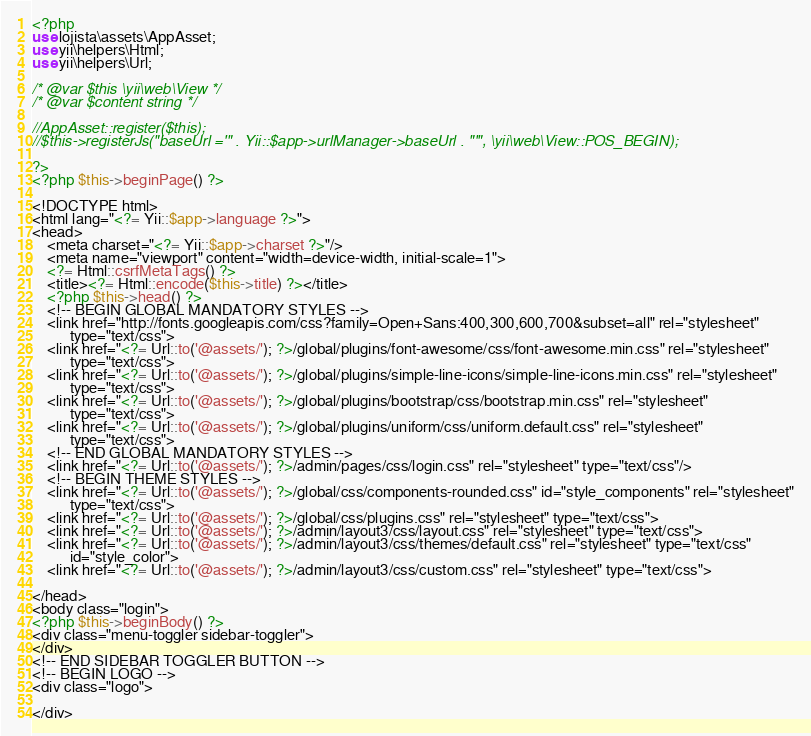<code> <loc_0><loc_0><loc_500><loc_500><_PHP_><?php
use lojista\assets\AppAsset;
use yii\helpers\Html;
use yii\helpers\Url;

/* @var $this \yii\web\View */
/* @var $content string */

//AppAsset::register($this);
//$this->registerJs("baseUrl ='" . Yii::$app->urlManager->baseUrl . "'", \yii\web\View::POS_BEGIN);

?>
<?php $this->beginPage() ?>

<!DOCTYPE html>
<html lang="<?= Yii::$app->language ?>">
<head>
    <meta charset="<?= Yii::$app->charset ?>"/>
    <meta name="viewport" content="width=device-width, initial-scale=1">
    <?= Html::csrfMetaTags() ?>
    <title><?= Html::encode($this->title) ?></title>
    <?php $this->head() ?>
    <!-- BEGIN GLOBAL MANDATORY STYLES -->
    <link href="http://fonts.googleapis.com/css?family=Open+Sans:400,300,600,700&subset=all" rel="stylesheet"
          type="text/css">
    <link href="<?= Url::to('@assets/'); ?>/global/plugins/font-awesome/css/font-awesome.min.css" rel="stylesheet"
          type="text/css">
    <link href="<?= Url::to('@assets/'); ?>/global/plugins/simple-line-icons/simple-line-icons.min.css" rel="stylesheet"
          type="text/css">
    <link href="<?= Url::to('@assets/'); ?>/global/plugins/bootstrap/css/bootstrap.min.css" rel="stylesheet"
          type="text/css">
    <link href="<?= Url::to('@assets/'); ?>/global/plugins/uniform/css/uniform.default.css" rel="stylesheet"
          type="text/css">
    <!-- END GLOBAL MANDATORY STYLES -->
    <link href="<?= Url::to('@assets/'); ?>/admin/pages/css/login.css" rel="stylesheet" type="text/css"/>
    <!-- BEGIN THEME STYLES -->
    <link href="<?= Url::to('@assets/'); ?>/global/css/components-rounded.css" id="style_components" rel="stylesheet"
          type="text/css">
    <link href="<?= Url::to('@assets/'); ?>/global/css/plugins.css" rel="stylesheet" type="text/css">
    <link href="<?= Url::to('@assets/'); ?>/admin/layout3/css/layout.css" rel="stylesheet" type="text/css">
    <link href="<?= Url::to('@assets/'); ?>/admin/layout3/css/themes/default.css" rel="stylesheet" type="text/css"
          id="style_color">
    <link href="<?= Url::to('@assets/'); ?>/admin/layout3/css/custom.css" rel="stylesheet" type="text/css">

</head>
<body class="login">
<?php $this->beginBody() ?>
<div class="menu-toggler sidebar-toggler">
</div>
<!-- END SIDEBAR TOGGLER BUTTON -->
<!-- BEGIN LOGO -->
<div class="logo">

</div></code> 